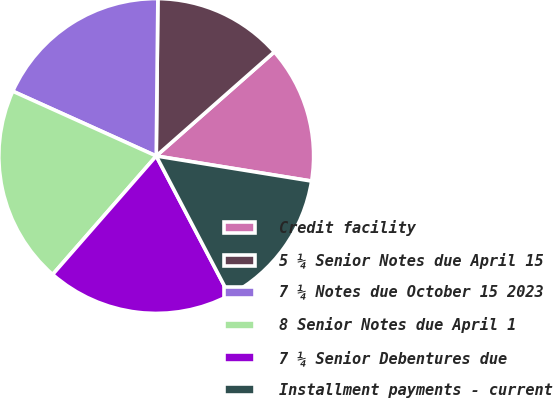Convert chart to OTSL. <chart><loc_0><loc_0><loc_500><loc_500><pie_chart><fcel>Credit facility<fcel>5 ¼ Senior Notes due April 15<fcel>7 ¼ Notes due October 15 2023<fcel>8 Senior Notes due April 1<fcel>7 ¼ Senior Debentures due<fcel>Installment payments - current<nl><fcel>14.05%<fcel>13.34%<fcel>18.42%<fcel>20.32%<fcel>19.13%<fcel>14.76%<nl></chart> 